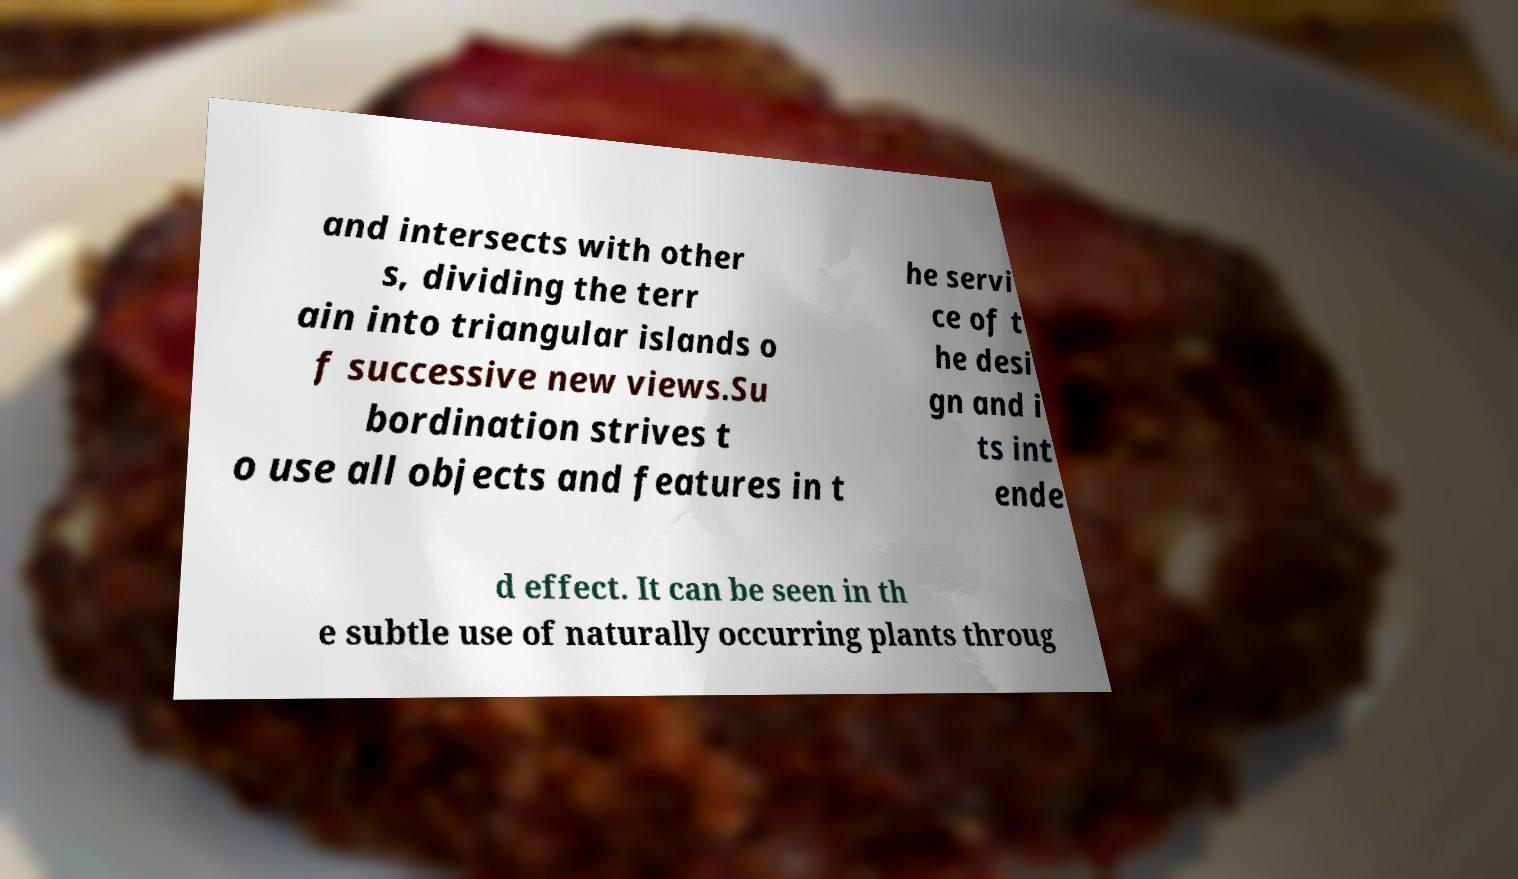I need the written content from this picture converted into text. Can you do that? and intersects with other s, dividing the terr ain into triangular islands o f successive new views.Su bordination strives t o use all objects and features in t he servi ce of t he desi gn and i ts int ende d effect. It can be seen in th e subtle use of naturally occurring plants throug 